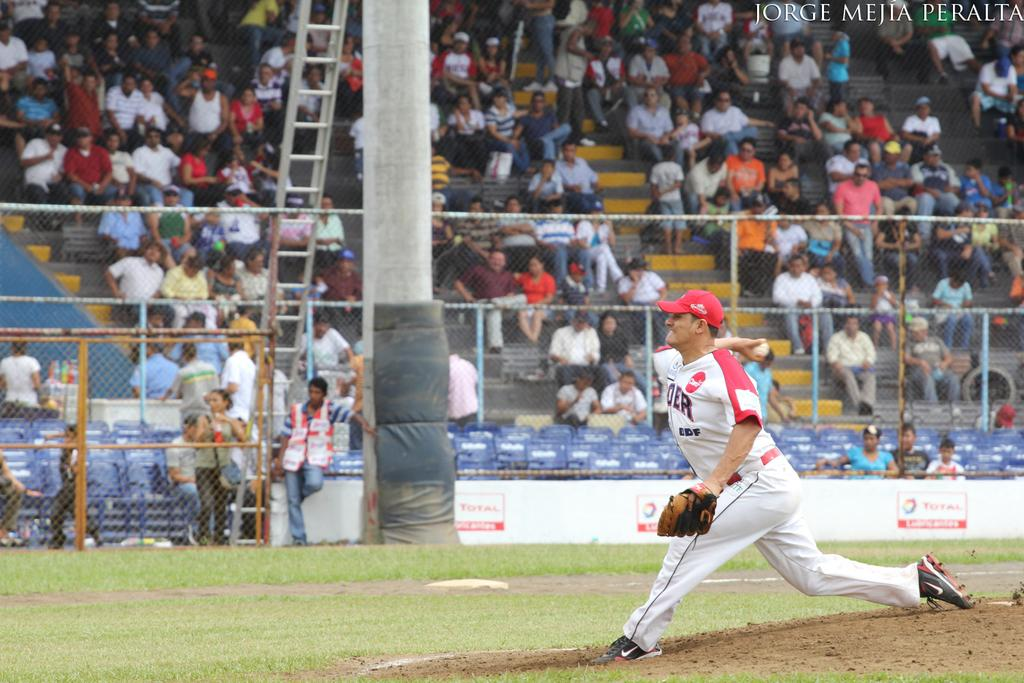<image>
Render a clear and concise summary of the photo. A pitcher thows the ball in front of a crowd in this photo that says Jorge Mejia Peralta in the upper corner. 